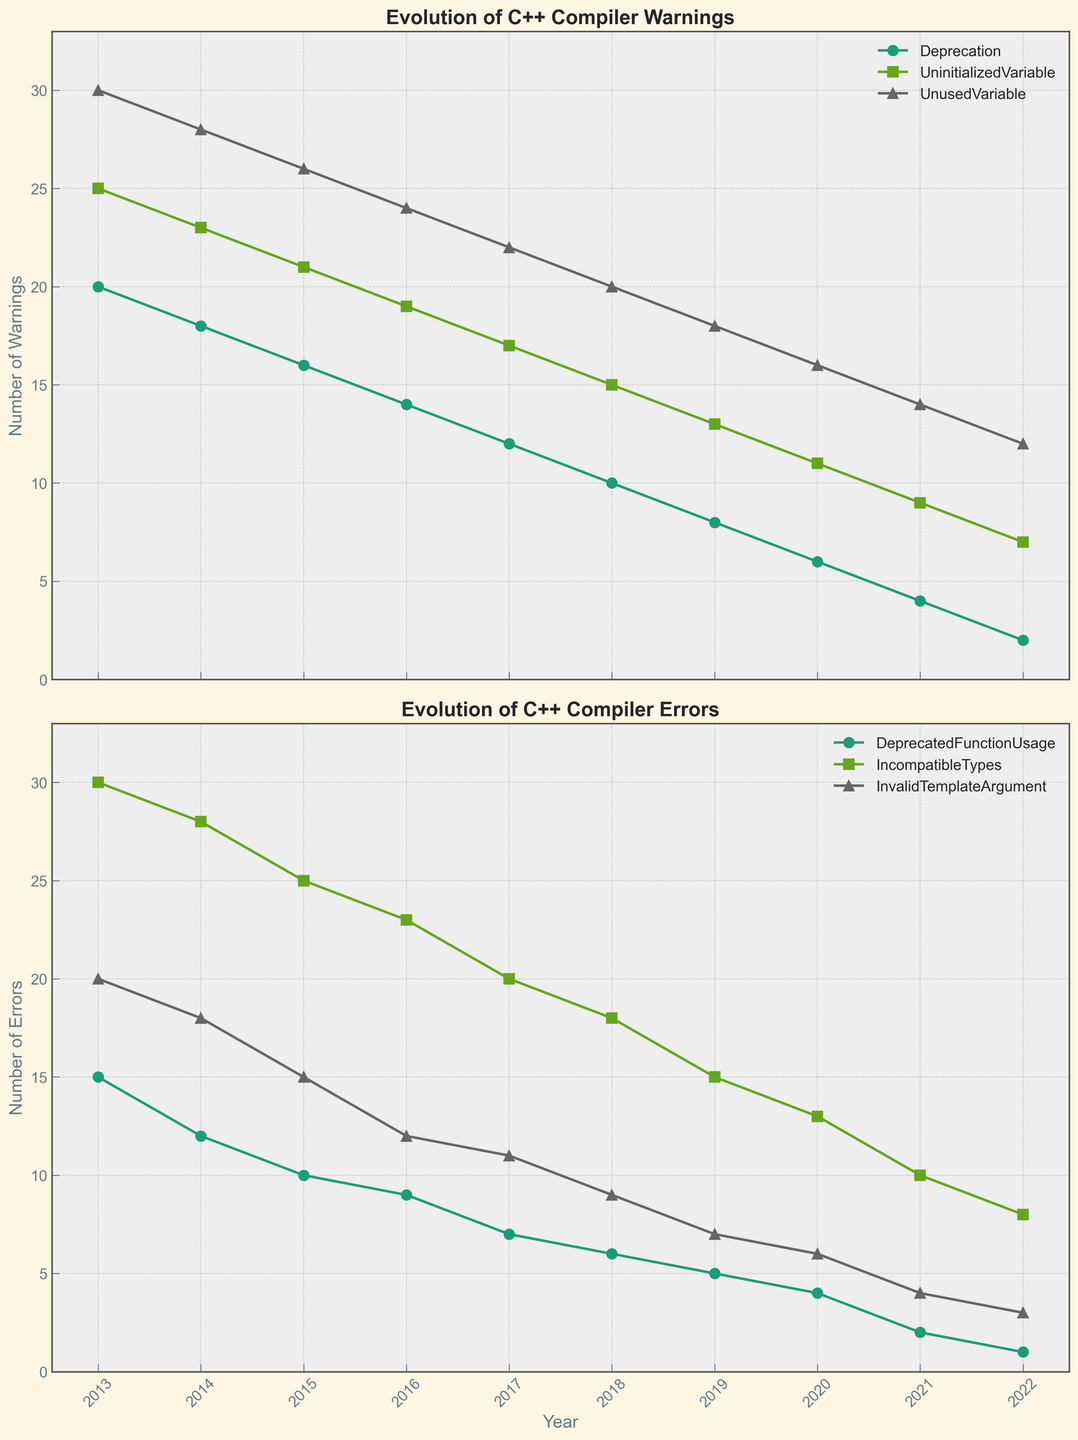What's the title of the top plot? The title of the top plot is visible above the graph area. Simply look at the text displayed at the top of the first subplot.
Answer: Evolution of C++ Compiler Warnings How many warning types are depicted in the figure? Count the distinct labels in the legend of the top subplot to determine the number of warning types shown.
Answer: 3 Which error type shows a consistent decrease over the years? Examine the trends of the lines in the bottom plot. Identify the line that steadily declines without interruptions.
Answer: DeprecatedFunctionUsage What warning type remained above 15 until after 2017? Observe the data points on the top plot. Identify which colored line stays above the 15 mark until around the year 2017.
Answer: UninitializedVariable In what year was the 'UnusedVariable' warning 14? On the top plot, locate the line for 'UnusedVariable' and find the corresponding year when its value was 14.
Answer: 2021 What is the average number of 'IncompatibleTypes' errors from 2013 to 2022? Sum the values of 'IncompatibleTypes' errors for each year from 2013 to 2022 and then divide by the number of years (10). Detailed: Sum (30 + 28 + 25 + 23 + 20 + 18 + 15 + 13 + 10 + 8) = 190. Average: 190 / 10 = 19.
Answer: 19 Which year did the 'UnusedVariable' warning reach the same number as the 'IncompatibleTypes' error? Compare the data points on both plots. Look for the year where the value of 'UnusedVariable' equals the value of 'IncompatibleTypes'.
Answer: 2020 What is the percentage decrease in 'DeprecatedFunctionUsage' errors from 2013 to 2022? Calculate the decrease from 15 to 1. Formula: ((15 - 1) / 15) * 100 = 93.33%.
Answer: 93.33% Which warning type showed the most significant reduction over the decade? Assess the distance between the initial and final points of each line in the top plot to determine which warning type had the maximum reduction.
Answer: UnusedVariable How does the trend of 'Deprecation' warnings compare to 'DeprecatedFunctionUsage' errors over the years? Analyze both lines on their respective plots and determine if they both decrease at a similar rate or show different trends.
Answer: Similar downward trend 